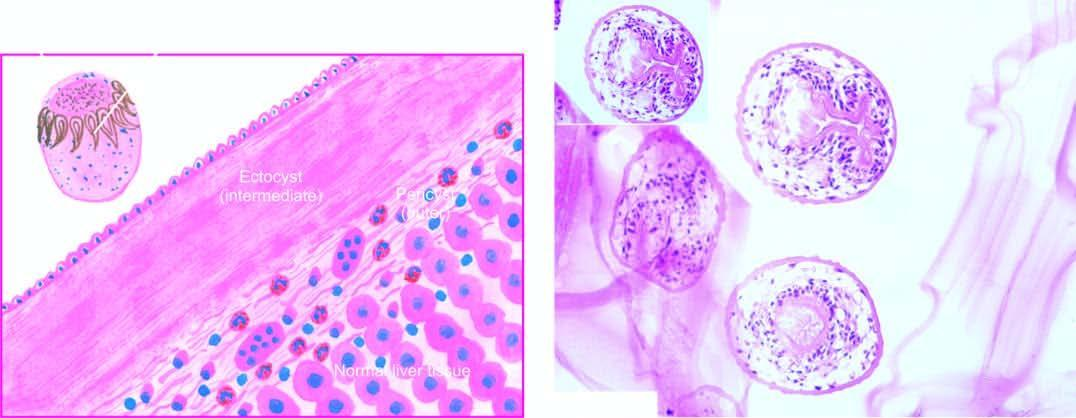what shows three layers in the wall of hydatid cyst?
Answer the question using a single word or phrase. Microscopy 